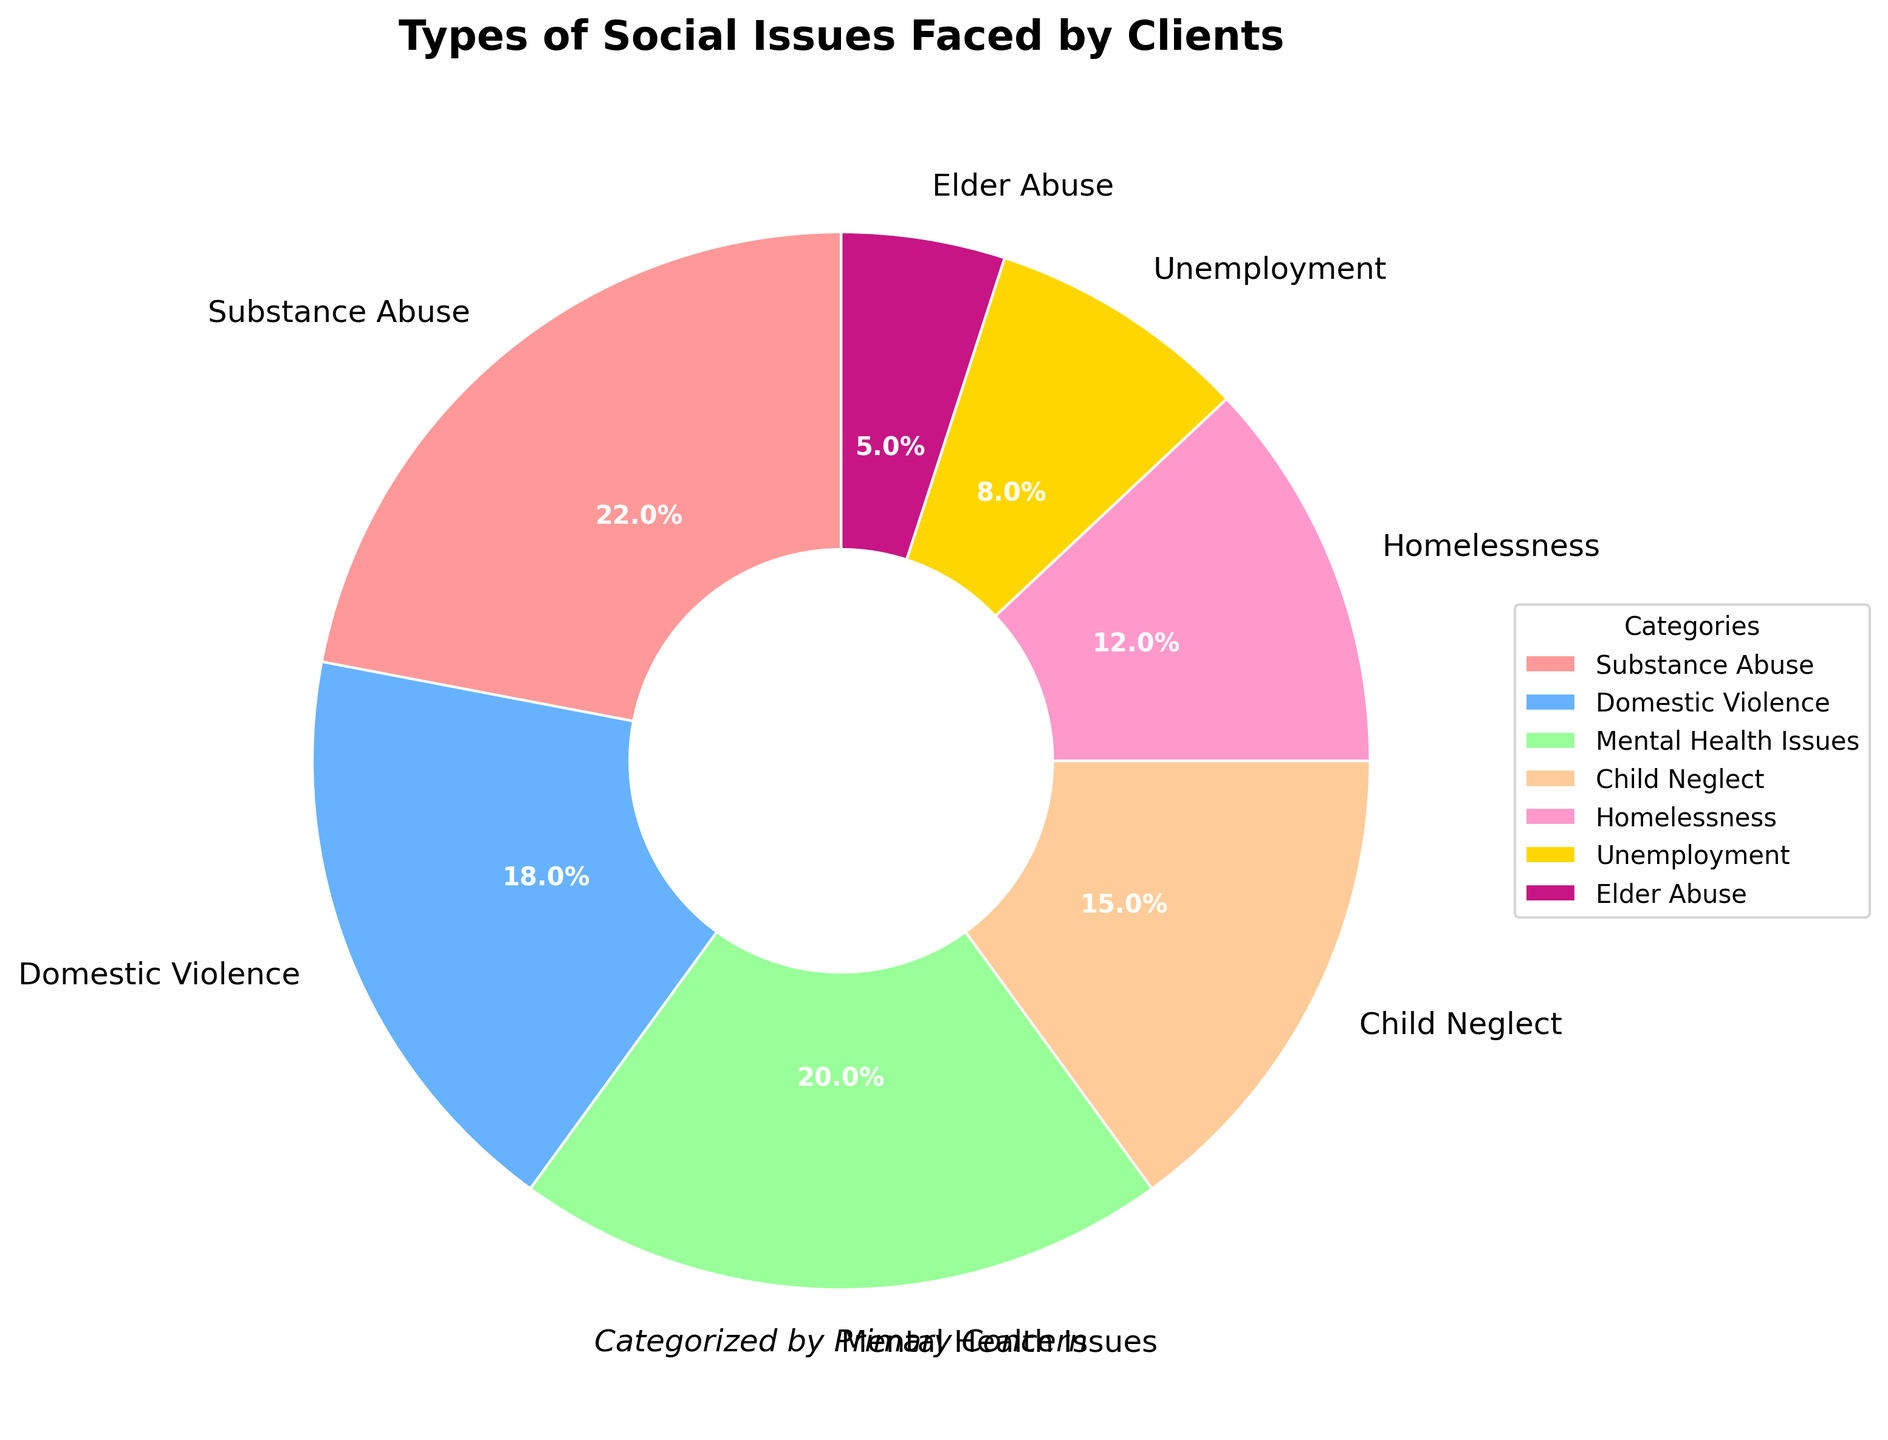What percentage of clients face Mental Health Issues? The pie chart shows a sector labeled "Mental Health Issues" which corresponds to 20%.
Answer: 20% Which social issue affects more clients: Domestic Violence or Homelessness? According to the pie chart, Domestic Violence affects 18% of clients while Homelessness affects 12%. Therefore, Domestic Violence affects more clients.
Answer: Domestic Violence What is the combined percentage of clients dealing with Child Neglect and Substance Abuse? According to the pie chart, Child Neglect affects 15% and Substance Abuse affects 22%. Adding these together, 15% + 22% = 37%.
Answer: 37% Are there more clients dealing with Unemployment or Elder Abuse? The pie chart shows that 8% of clients deal with Unemployment, while 5% deal with Elder Abuse. Hence, more clients are dealing with Unemployment.
Answer: Unemployment Which three social issues have the highest percentages? The pie chart indicates that Substance Abuse has 22%, Mental Health Issues has 20%, and Domestic Violence has 18%. These three categories have the highest percentages.
Answer: Substance Abuse, Mental Health Issues, Domestic Violence How many percentage points higher is the issue of Mental Health Issues compared to Unemployment? The pie chart shows that Mental Health Issues account for 20% and Unemployment accounts for 8%. The difference is 20% - 8% = 12%.
Answer: 12% What is the total percentage of clients facing issues other than Substance Abuse, Domestic Violence, and Mental Health Issues? The percentages for Substance Abuse, Domestic Violence, and Mental Health Issues are 22%, 18%, and 20%, respectively. Summing these gives 22% + 18% + 20% = 60%. Therefore, the total for the other issues is 100% - 60% = 40%.
Answer: 40% Which category is represented by the yellow color in the pie chart? The pie chart uses distinct colors for each category. The yellow color corresponds to Unemployment, which accounts for 8%.
Answer: Unemployment 